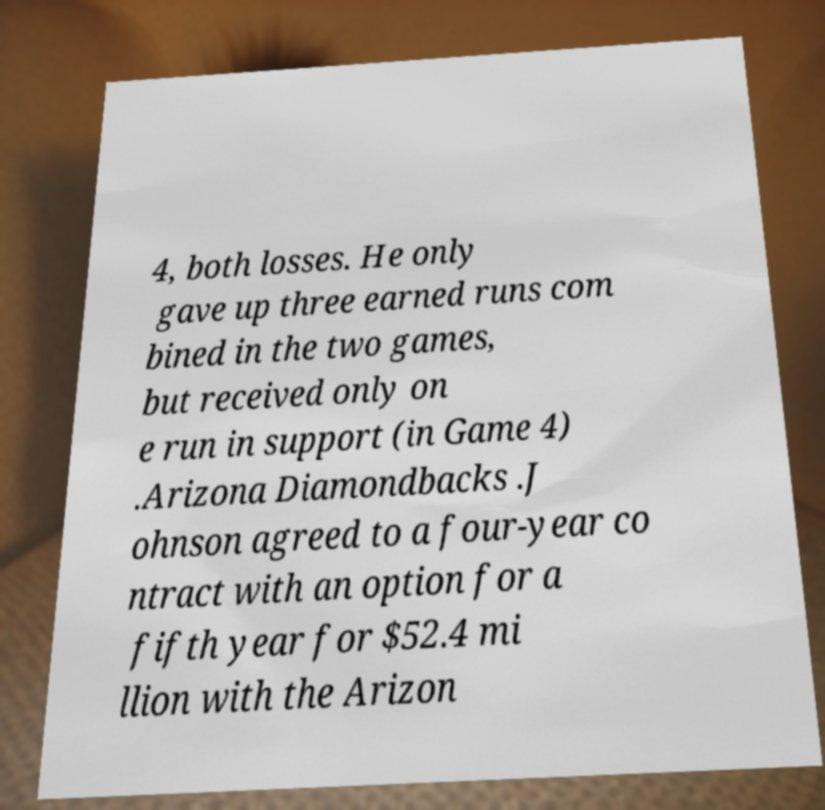Could you extract and type out the text from this image? 4, both losses. He only gave up three earned runs com bined in the two games, but received only on e run in support (in Game 4) .Arizona Diamondbacks .J ohnson agreed to a four-year co ntract with an option for a fifth year for $52.4 mi llion with the Arizon 